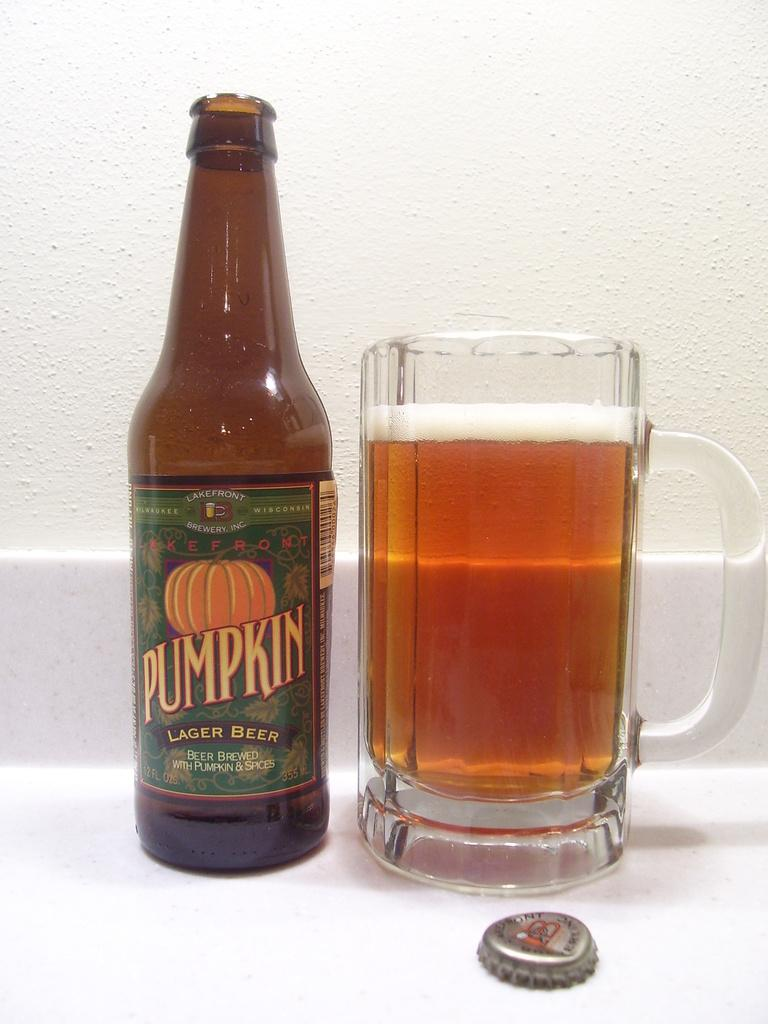<image>
Describe the image concisely. A bottle of Pumpkin Lager Beer and and glass of beer. 